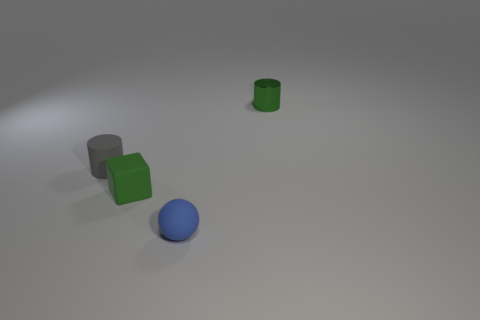Is the color of the metal thing the same as the tiny cube?
Ensure brevity in your answer.  Yes. The shiny object that is the same color as the cube is what size?
Keep it short and to the point. Small. How many things are large blue spheres or small gray objects?
Keep it short and to the point. 1. How many other things are the same size as the gray thing?
Provide a succinct answer. 3. There is a block; is its color the same as the small cylinder that is right of the tiny green matte block?
Your answer should be compact. Yes. What number of blocks are big yellow metallic things or green things?
Your answer should be compact. 1. Is there any other thing that has the same color as the matte cylinder?
Ensure brevity in your answer.  No. There is a green thing in front of the matte thing that is on the left side of the green cube; what is its material?
Provide a short and direct response. Rubber. Are the green cube and the cylinder that is on the left side of the tiny blue thing made of the same material?
Your answer should be very brief. Yes. How many things are either rubber spheres on the left side of the green shiny thing or tiny green blocks?
Your answer should be compact. 2. 